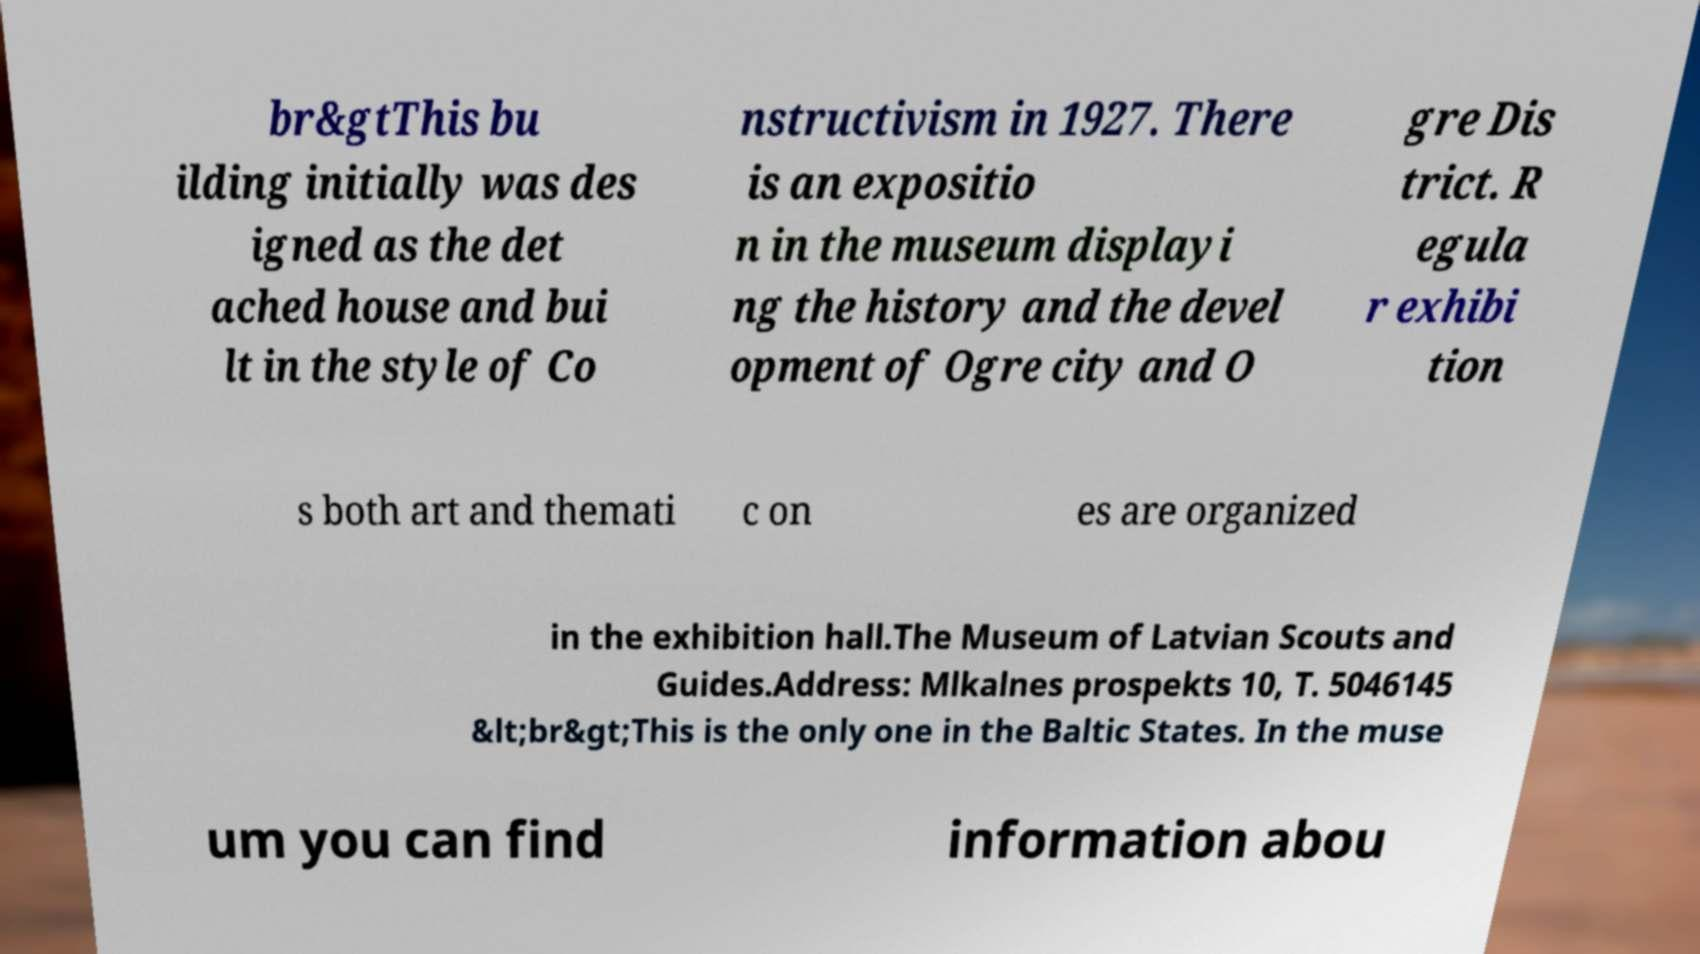Can you read and provide the text displayed in the image?This photo seems to have some interesting text. Can you extract and type it out for me? br&gtThis bu ilding initially was des igned as the det ached house and bui lt in the style of Co nstructivism in 1927. There is an expositio n in the museum displayi ng the history and the devel opment of Ogre city and O gre Dis trict. R egula r exhibi tion s both art and themati c on es are organized in the exhibition hall.The Museum of Latvian Scouts and Guides.Address: Mlkalnes prospekts 10, T. 5046145 &lt;br&gt;This is the only one in the Baltic States. In the muse um you can find information abou 